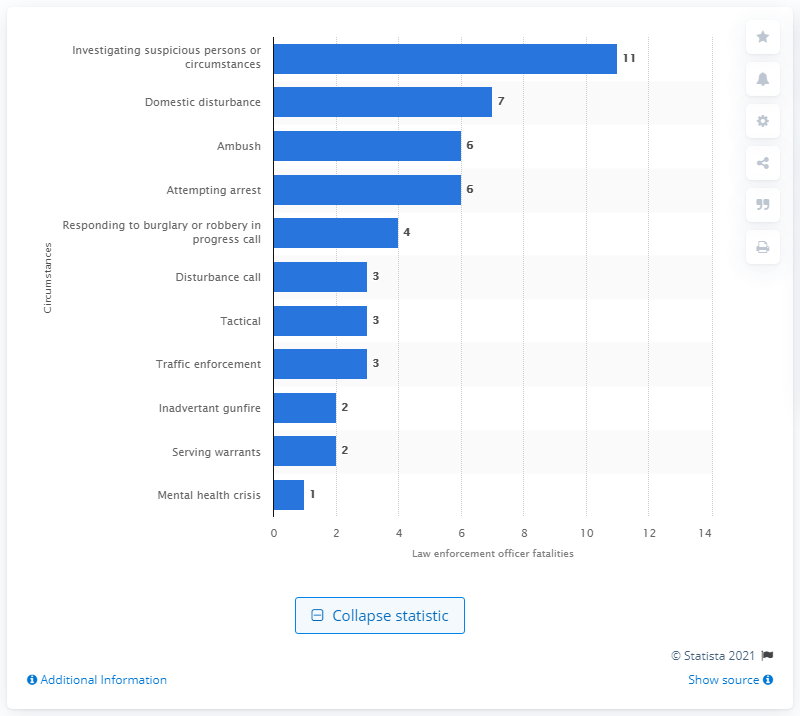Mention a couple of crucial points in this snapshot. In 2020, 11 law enforcement officers were killed. 